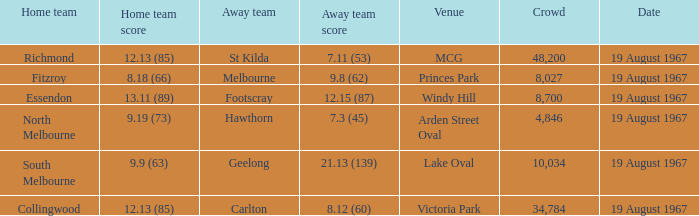If the opposing team scored 9.19 (73). Write the full table. {'header': ['Home team', 'Home team score', 'Away team', 'Away team score', 'Venue', 'Crowd', 'Date'], 'rows': [['Richmond', '12.13 (85)', 'St Kilda', '7.11 (53)', 'MCG', '48,200', '19 August 1967'], ['Fitzroy', '8.18 (66)', 'Melbourne', '9.8 (62)', 'Princes Park', '8,027', '19 August 1967'], ['Essendon', '13.11 (89)', 'Footscray', '12.15 (87)', 'Windy Hill', '8,700', '19 August 1967'], ['North Melbourne', '9.19 (73)', 'Hawthorn', '7.3 (45)', 'Arden Street Oval', '4,846', '19 August 1967'], ['South Melbourne', '9.9 (63)', 'Geelong', '21.13 (139)', 'Lake Oval', '10,034', '19 August 1967'], ['Collingwood', '12.13 (85)', 'Carlton', '8.12 (60)', 'Victoria Park', '34,784', '19 August 1967']]} 